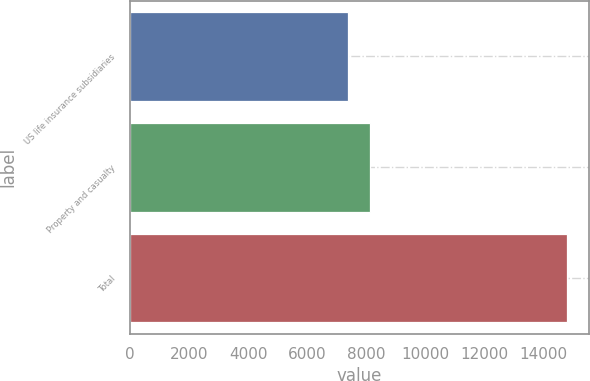Convert chart to OTSL. <chart><loc_0><loc_0><loc_500><loc_500><bar_chart><fcel>US life insurance subsidiaries<fcel>Property and casualty<fcel>Total<nl><fcel>7388<fcel>8129.2<fcel>14800<nl></chart> 